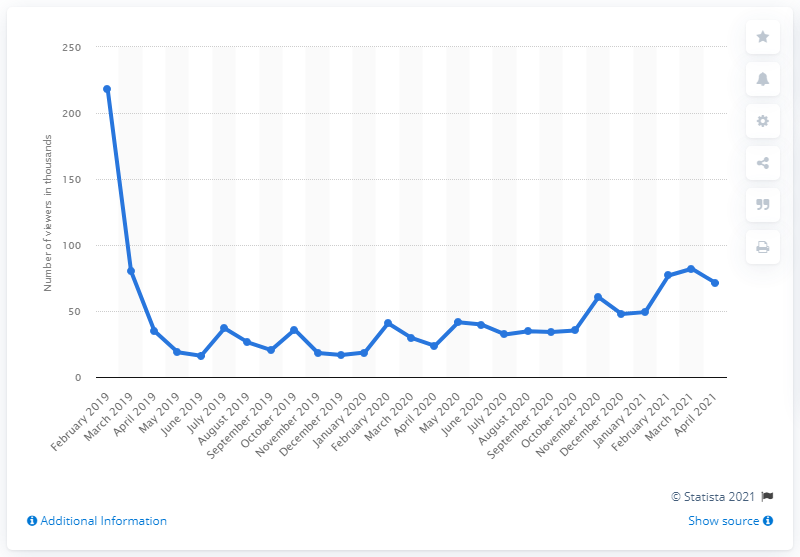Mention a couple of crucial points in this snapshot. Apex Legends was released in February 2019. 